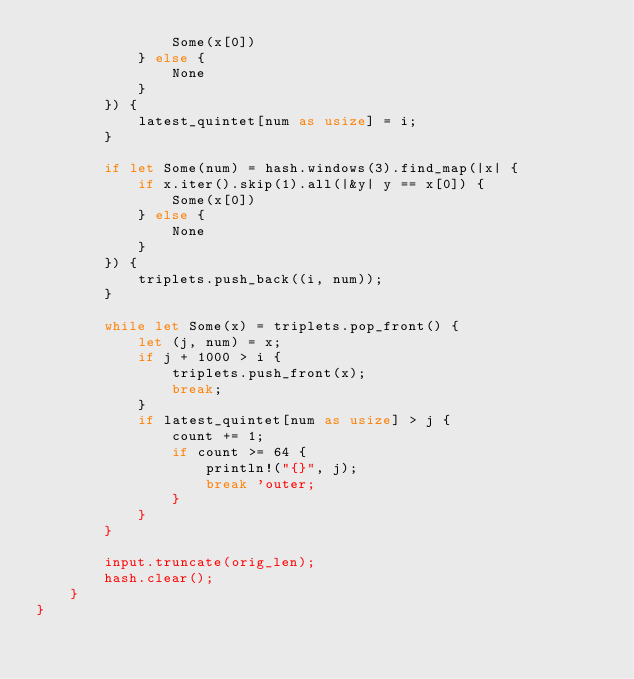<code> <loc_0><loc_0><loc_500><loc_500><_Rust_>                Some(x[0])
            } else {
                None
            }
        }) {
            latest_quintet[num as usize] = i;
        }

        if let Some(num) = hash.windows(3).find_map(|x| {
            if x.iter().skip(1).all(|&y| y == x[0]) {
                Some(x[0])
            } else {
                None
            }
        }) {
            triplets.push_back((i, num));
        }

        while let Some(x) = triplets.pop_front() {
            let (j, num) = x;
            if j + 1000 > i {
                triplets.push_front(x);
                break;
            }
            if latest_quintet[num as usize] > j {
                count += 1;
                if count >= 64 {
                    println!("{}", j);
                    break 'outer;
                }
            }
        }

        input.truncate(orig_len);
        hash.clear();
    }
}
</code> 